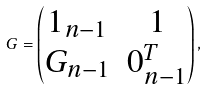Convert formula to latex. <formula><loc_0><loc_0><loc_500><loc_500>G = \begin{pmatrix} 1 _ { n - 1 } & 1 \\ G _ { n - 1 } & 0 _ { n - 1 } ^ { T } \end{pmatrix} ,</formula> 